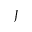<formula> <loc_0><loc_0><loc_500><loc_500>J</formula> 